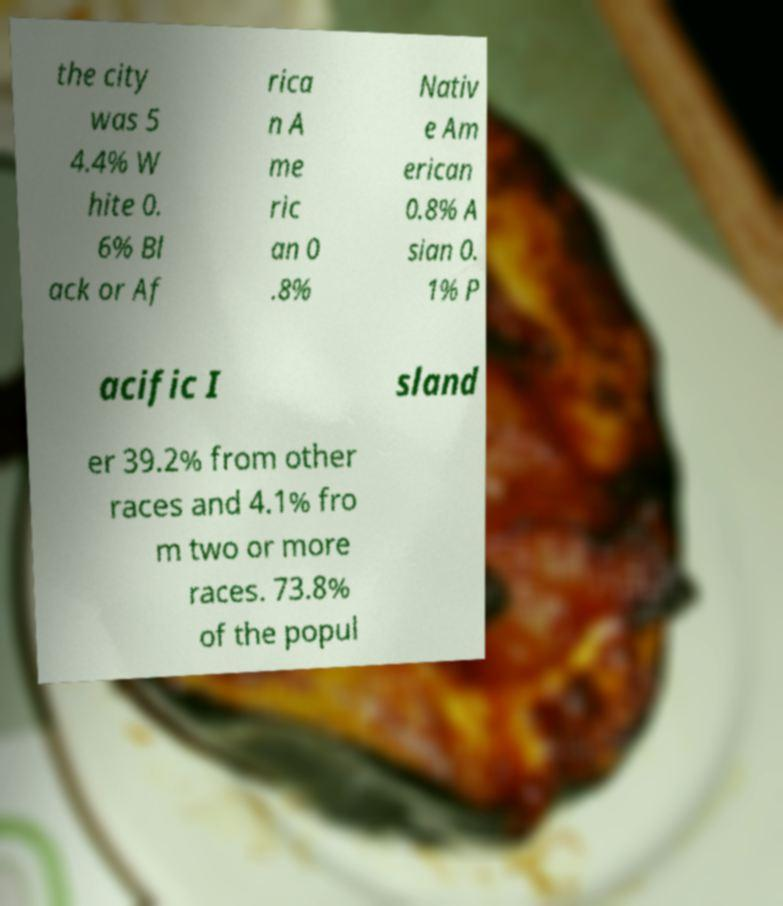Could you extract and type out the text from this image? the city was 5 4.4% W hite 0. 6% Bl ack or Af rica n A me ric an 0 .8% Nativ e Am erican 0.8% A sian 0. 1% P acific I sland er 39.2% from other races and 4.1% fro m two or more races. 73.8% of the popul 